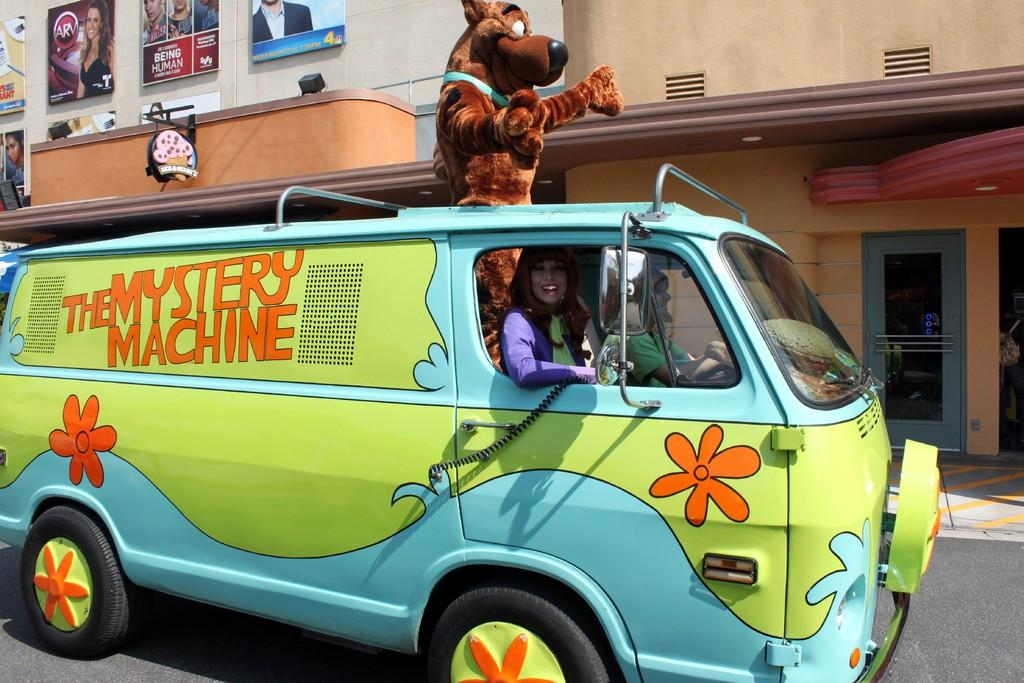What is the main subject in the middle of the image? There is a vehicle in the middle of the image. Who is inside the vehicle? A woman is inside the vehicle. What other object is in the middle of the image? There is a teddy bear in the middle of the image. What can be seen in the background of the image? There is a building in the background of the image. What type of soda is the woman drinking in the image? There is no soda present in the image; the woman is inside a vehicle with a teddy bear. Who is the woman's partner in the image? There is no mention of a partner in the image; it only shows a woman inside a vehicle with a teddy bear and a building in the background. 